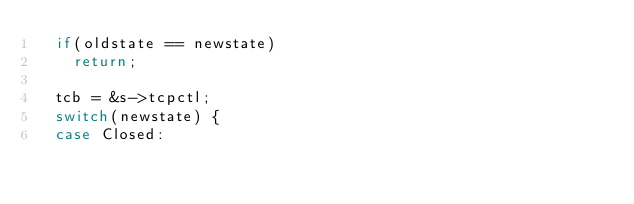<code> <loc_0><loc_0><loc_500><loc_500><_C_>	if(oldstate == newstate)
		return;

	tcb = &s->tcpctl;
	switch(newstate) {
	case Closed:</code> 